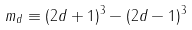Convert formula to latex. <formula><loc_0><loc_0><loc_500><loc_500>m _ { d } \equiv ( 2 d + 1 ) ^ { 3 } - ( 2 d - 1 ) ^ { 3 }</formula> 